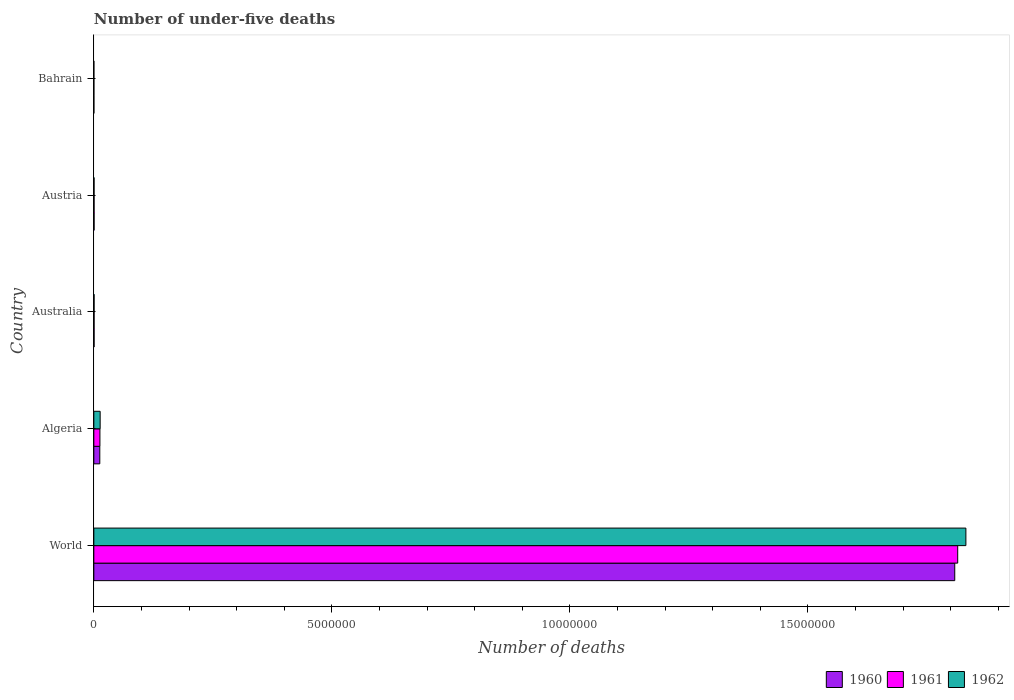How many different coloured bars are there?
Ensure brevity in your answer.  3. How many groups of bars are there?
Your response must be concise. 5. Are the number of bars on each tick of the Y-axis equal?
Make the answer very short. Yes. How many bars are there on the 4th tick from the top?
Provide a short and direct response. 3. How many bars are there on the 5th tick from the bottom?
Offer a very short reply. 3. What is the number of under-five deaths in 1962 in Bahrain?
Provide a succinct answer. 1207. Across all countries, what is the maximum number of under-five deaths in 1962?
Give a very brief answer. 1.83e+07. Across all countries, what is the minimum number of under-five deaths in 1961?
Provide a succinct answer. 1323. In which country was the number of under-five deaths in 1960 minimum?
Make the answer very short. Bahrain. What is the total number of under-five deaths in 1960 in the graph?
Your answer should be compact. 1.82e+07. What is the difference between the number of under-five deaths in 1961 in Algeria and that in Australia?
Ensure brevity in your answer.  1.23e+05. What is the difference between the number of under-five deaths in 1961 in Algeria and the number of under-five deaths in 1962 in World?
Offer a very short reply. -1.82e+07. What is the average number of under-five deaths in 1961 per country?
Provide a short and direct response. 3.66e+06. What is the difference between the number of under-five deaths in 1962 and number of under-five deaths in 1960 in Austria?
Your answer should be compact. -571. What is the ratio of the number of under-five deaths in 1960 in Bahrain to that in World?
Your answer should be compact. 7.79724335926479e-5. What is the difference between the highest and the second highest number of under-five deaths in 1962?
Offer a very short reply. 1.82e+07. What is the difference between the highest and the lowest number of under-five deaths in 1960?
Provide a short and direct response. 1.81e+07. In how many countries, is the number of under-five deaths in 1961 greater than the average number of under-five deaths in 1961 taken over all countries?
Keep it short and to the point. 1. Is the sum of the number of under-five deaths in 1960 in Algeria and Australia greater than the maximum number of under-five deaths in 1962 across all countries?
Provide a succinct answer. No. What does the 3rd bar from the bottom in Australia represents?
Provide a succinct answer. 1962. How many bars are there?
Provide a succinct answer. 15. Are all the bars in the graph horizontal?
Provide a succinct answer. Yes. Does the graph contain any zero values?
Provide a succinct answer. No. Does the graph contain grids?
Ensure brevity in your answer.  No. Where does the legend appear in the graph?
Keep it short and to the point. Bottom right. How many legend labels are there?
Your answer should be very brief. 3. How are the legend labels stacked?
Offer a terse response. Horizontal. What is the title of the graph?
Ensure brevity in your answer.  Number of under-five deaths. Does "2011" appear as one of the legend labels in the graph?
Your answer should be compact. No. What is the label or title of the X-axis?
Make the answer very short. Number of deaths. What is the Number of deaths in 1960 in World?
Offer a terse response. 1.81e+07. What is the Number of deaths of 1961 in World?
Provide a short and direct response. 1.81e+07. What is the Number of deaths of 1962 in World?
Keep it short and to the point. 1.83e+07. What is the Number of deaths of 1960 in Algeria?
Your response must be concise. 1.25e+05. What is the Number of deaths in 1961 in Algeria?
Give a very brief answer. 1.28e+05. What is the Number of deaths in 1962 in Algeria?
Offer a very short reply. 1.33e+05. What is the Number of deaths in 1960 in Australia?
Ensure brevity in your answer.  5775. What is the Number of deaths of 1961 in Australia?
Your response must be concise. 5722. What is the Number of deaths of 1962 in Australia?
Your answer should be compact. 5592. What is the Number of deaths in 1960 in Austria?
Provide a succinct answer. 5754. What is the Number of deaths in 1961 in Austria?
Provide a short and direct response. 5502. What is the Number of deaths in 1962 in Austria?
Your answer should be very brief. 5183. What is the Number of deaths of 1960 in Bahrain?
Your response must be concise. 1410. What is the Number of deaths of 1961 in Bahrain?
Provide a succinct answer. 1323. What is the Number of deaths of 1962 in Bahrain?
Your answer should be very brief. 1207. Across all countries, what is the maximum Number of deaths of 1960?
Ensure brevity in your answer.  1.81e+07. Across all countries, what is the maximum Number of deaths of 1961?
Ensure brevity in your answer.  1.81e+07. Across all countries, what is the maximum Number of deaths in 1962?
Your answer should be very brief. 1.83e+07. Across all countries, what is the minimum Number of deaths in 1960?
Make the answer very short. 1410. Across all countries, what is the minimum Number of deaths of 1961?
Give a very brief answer. 1323. Across all countries, what is the minimum Number of deaths of 1962?
Offer a terse response. 1207. What is the total Number of deaths in 1960 in the graph?
Your answer should be very brief. 1.82e+07. What is the total Number of deaths of 1961 in the graph?
Provide a succinct answer. 1.83e+07. What is the total Number of deaths in 1962 in the graph?
Give a very brief answer. 1.85e+07. What is the difference between the Number of deaths in 1960 in World and that in Algeria?
Your answer should be compact. 1.80e+07. What is the difference between the Number of deaths in 1961 in World and that in Algeria?
Provide a short and direct response. 1.80e+07. What is the difference between the Number of deaths of 1962 in World and that in Algeria?
Offer a terse response. 1.82e+07. What is the difference between the Number of deaths in 1960 in World and that in Australia?
Make the answer very short. 1.81e+07. What is the difference between the Number of deaths of 1961 in World and that in Australia?
Provide a short and direct response. 1.81e+07. What is the difference between the Number of deaths of 1962 in World and that in Australia?
Offer a terse response. 1.83e+07. What is the difference between the Number of deaths of 1960 in World and that in Austria?
Your answer should be very brief. 1.81e+07. What is the difference between the Number of deaths in 1961 in World and that in Austria?
Offer a very short reply. 1.81e+07. What is the difference between the Number of deaths in 1962 in World and that in Austria?
Ensure brevity in your answer.  1.83e+07. What is the difference between the Number of deaths of 1960 in World and that in Bahrain?
Offer a very short reply. 1.81e+07. What is the difference between the Number of deaths of 1961 in World and that in Bahrain?
Give a very brief answer. 1.81e+07. What is the difference between the Number of deaths in 1962 in World and that in Bahrain?
Ensure brevity in your answer.  1.83e+07. What is the difference between the Number of deaths in 1960 in Algeria and that in Australia?
Provide a short and direct response. 1.20e+05. What is the difference between the Number of deaths in 1961 in Algeria and that in Australia?
Your response must be concise. 1.23e+05. What is the difference between the Number of deaths of 1962 in Algeria and that in Australia?
Offer a very short reply. 1.27e+05. What is the difference between the Number of deaths in 1960 in Algeria and that in Austria?
Provide a short and direct response. 1.20e+05. What is the difference between the Number of deaths of 1961 in Algeria and that in Austria?
Your answer should be very brief. 1.23e+05. What is the difference between the Number of deaths of 1962 in Algeria and that in Austria?
Your answer should be compact. 1.28e+05. What is the difference between the Number of deaths in 1960 in Algeria and that in Bahrain?
Provide a succinct answer. 1.24e+05. What is the difference between the Number of deaths of 1961 in Algeria and that in Bahrain?
Provide a short and direct response. 1.27e+05. What is the difference between the Number of deaths in 1962 in Algeria and that in Bahrain?
Make the answer very short. 1.32e+05. What is the difference between the Number of deaths of 1961 in Australia and that in Austria?
Keep it short and to the point. 220. What is the difference between the Number of deaths of 1962 in Australia and that in Austria?
Offer a terse response. 409. What is the difference between the Number of deaths in 1960 in Australia and that in Bahrain?
Offer a very short reply. 4365. What is the difference between the Number of deaths in 1961 in Australia and that in Bahrain?
Keep it short and to the point. 4399. What is the difference between the Number of deaths of 1962 in Australia and that in Bahrain?
Make the answer very short. 4385. What is the difference between the Number of deaths in 1960 in Austria and that in Bahrain?
Keep it short and to the point. 4344. What is the difference between the Number of deaths in 1961 in Austria and that in Bahrain?
Provide a succinct answer. 4179. What is the difference between the Number of deaths of 1962 in Austria and that in Bahrain?
Provide a short and direct response. 3976. What is the difference between the Number of deaths in 1960 in World and the Number of deaths in 1961 in Algeria?
Offer a terse response. 1.80e+07. What is the difference between the Number of deaths of 1960 in World and the Number of deaths of 1962 in Algeria?
Make the answer very short. 1.80e+07. What is the difference between the Number of deaths of 1961 in World and the Number of deaths of 1962 in Algeria?
Offer a very short reply. 1.80e+07. What is the difference between the Number of deaths in 1960 in World and the Number of deaths in 1961 in Australia?
Provide a succinct answer. 1.81e+07. What is the difference between the Number of deaths of 1960 in World and the Number of deaths of 1962 in Australia?
Offer a terse response. 1.81e+07. What is the difference between the Number of deaths in 1961 in World and the Number of deaths in 1962 in Australia?
Your answer should be very brief. 1.81e+07. What is the difference between the Number of deaths of 1960 in World and the Number of deaths of 1961 in Austria?
Give a very brief answer. 1.81e+07. What is the difference between the Number of deaths in 1960 in World and the Number of deaths in 1962 in Austria?
Your response must be concise. 1.81e+07. What is the difference between the Number of deaths in 1961 in World and the Number of deaths in 1962 in Austria?
Your response must be concise. 1.81e+07. What is the difference between the Number of deaths of 1960 in World and the Number of deaths of 1961 in Bahrain?
Provide a succinct answer. 1.81e+07. What is the difference between the Number of deaths of 1960 in World and the Number of deaths of 1962 in Bahrain?
Provide a succinct answer. 1.81e+07. What is the difference between the Number of deaths of 1961 in World and the Number of deaths of 1962 in Bahrain?
Keep it short and to the point. 1.81e+07. What is the difference between the Number of deaths of 1960 in Algeria and the Number of deaths of 1961 in Australia?
Make the answer very short. 1.20e+05. What is the difference between the Number of deaths in 1960 in Algeria and the Number of deaths in 1962 in Australia?
Your answer should be compact. 1.20e+05. What is the difference between the Number of deaths in 1961 in Algeria and the Number of deaths in 1962 in Australia?
Your answer should be very brief. 1.23e+05. What is the difference between the Number of deaths of 1960 in Algeria and the Number of deaths of 1961 in Austria?
Ensure brevity in your answer.  1.20e+05. What is the difference between the Number of deaths in 1960 in Algeria and the Number of deaths in 1962 in Austria?
Your response must be concise. 1.20e+05. What is the difference between the Number of deaths of 1961 in Algeria and the Number of deaths of 1962 in Austria?
Your answer should be compact. 1.23e+05. What is the difference between the Number of deaths in 1960 in Algeria and the Number of deaths in 1961 in Bahrain?
Offer a terse response. 1.24e+05. What is the difference between the Number of deaths of 1960 in Algeria and the Number of deaths of 1962 in Bahrain?
Offer a very short reply. 1.24e+05. What is the difference between the Number of deaths of 1961 in Algeria and the Number of deaths of 1962 in Bahrain?
Offer a terse response. 1.27e+05. What is the difference between the Number of deaths in 1960 in Australia and the Number of deaths in 1961 in Austria?
Keep it short and to the point. 273. What is the difference between the Number of deaths of 1960 in Australia and the Number of deaths of 1962 in Austria?
Offer a terse response. 592. What is the difference between the Number of deaths of 1961 in Australia and the Number of deaths of 1962 in Austria?
Keep it short and to the point. 539. What is the difference between the Number of deaths of 1960 in Australia and the Number of deaths of 1961 in Bahrain?
Provide a short and direct response. 4452. What is the difference between the Number of deaths in 1960 in Australia and the Number of deaths in 1962 in Bahrain?
Provide a short and direct response. 4568. What is the difference between the Number of deaths in 1961 in Australia and the Number of deaths in 1962 in Bahrain?
Your answer should be very brief. 4515. What is the difference between the Number of deaths of 1960 in Austria and the Number of deaths of 1961 in Bahrain?
Give a very brief answer. 4431. What is the difference between the Number of deaths of 1960 in Austria and the Number of deaths of 1962 in Bahrain?
Offer a very short reply. 4547. What is the difference between the Number of deaths of 1961 in Austria and the Number of deaths of 1962 in Bahrain?
Offer a terse response. 4295. What is the average Number of deaths of 1960 per country?
Your answer should be compact. 3.64e+06. What is the average Number of deaths in 1961 per country?
Make the answer very short. 3.66e+06. What is the average Number of deaths in 1962 per country?
Give a very brief answer. 3.69e+06. What is the difference between the Number of deaths in 1960 and Number of deaths in 1961 in World?
Give a very brief answer. -6.21e+04. What is the difference between the Number of deaths of 1960 and Number of deaths of 1962 in World?
Offer a very short reply. -2.34e+05. What is the difference between the Number of deaths of 1961 and Number of deaths of 1962 in World?
Keep it short and to the point. -1.72e+05. What is the difference between the Number of deaths of 1960 and Number of deaths of 1961 in Algeria?
Your answer should be very brief. -2789. What is the difference between the Number of deaths of 1960 and Number of deaths of 1962 in Algeria?
Keep it short and to the point. -7580. What is the difference between the Number of deaths of 1961 and Number of deaths of 1962 in Algeria?
Make the answer very short. -4791. What is the difference between the Number of deaths of 1960 and Number of deaths of 1961 in Australia?
Provide a succinct answer. 53. What is the difference between the Number of deaths in 1960 and Number of deaths in 1962 in Australia?
Ensure brevity in your answer.  183. What is the difference between the Number of deaths of 1961 and Number of deaths of 1962 in Australia?
Your answer should be very brief. 130. What is the difference between the Number of deaths of 1960 and Number of deaths of 1961 in Austria?
Your answer should be very brief. 252. What is the difference between the Number of deaths in 1960 and Number of deaths in 1962 in Austria?
Ensure brevity in your answer.  571. What is the difference between the Number of deaths of 1961 and Number of deaths of 1962 in Austria?
Provide a short and direct response. 319. What is the difference between the Number of deaths in 1960 and Number of deaths in 1962 in Bahrain?
Your answer should be very brief. 203. What is the difference between the Number of deaths in 1961 and Number of deaths in 1962 in Bahrain?
Keep it short and to the point. 116. What is the ratio of the Number of deaths of 1960 in World to that in Algeria?
Your answer should be very brief. 144.14. What is the ratio of the Number of deaths of 1961 in World to that in Algeria?
Provide a short and direct response. 141.49. What is the ratio of the Number of deaths in 1962 in World to that in Algeria?
Offer a very short reply. 137.69. What is the ratio of the Number of deaths of 1960 in World to that in Australia?
Make the answer very short. 3131.31. What is the ratio of the Number of deaths of 1961 in World to that in Australia?
Your answer should be compact. 3171.17. What is the ratio of the Number of deaths of 1962 in World to that in Australia?
Give a very brief answer. 3275.65. What is the ratio of the Number of deaths in 1960 in World to that in Austria?
Your answer should be compact. 3142.74. What is the ratio of the Number of deaths of 1961 in World to that in Austria?
Your answer should be very brief. 3297.97. What is the ratio of the Number of deaths in 1962 in World to that in Austria?
Keep it short and to the point. 3534.14. What is the ratio of the Number of deaths of 1960 in World to that in Bahrain?
Your answer should be very brief. 1.28e+04. What is the ratio of the Number of deaths of 1961 in World to that in Bahrain?
Offer a very short reply. 1.37e+04. What is the ratio of the Number of deaths in 1962 in World to that in Bahrain?
Provide a short and direct response. 1.52e+04. What is the ratio of the Number of deaths of 1960 in Algeria to that in Australia?
Provide a succinct answer. 21.72. What is the ratio of the Number of deaths in 1961 in Algeria to that in Australia?
Keep it short and to the point. 22.41. What is the ratio of the Number of deaths of 1962 in Algeria to that in Australia?
Offer a very short reply. 23.79. What is the ratio of the Number of deaths in 1960 in Algeria to that in Austria?
Provide a short and direct response. 21.8. What is the ratio of the Number of deaths of 1961 in Algeria to that in Austria?
Offer a terse response. 23.31. What is the ratio of the Number of deaths in 1962 in Algeria to that in Austria?
Offer a very short reply. 25.67. What is the ratio of the Number of deaths of 1960 in Algeria to that in Bahrain?
Your response must be concise. 88.97. What is the ratio of the Number of deaths of 1961 in Algeria to that in Bahrain?
Make the answer very short. 96.93. What is the ratio of the Number of deaths in 1962 in Algeria to that in Bahrain?
Your answer should be very brief. 110.22. What is the ratio of the Number of deaths in 1960 in Australia to that in Austria?
Your answer should be very brief. 1. What is the ratio of the Number of deaths of 1961 in Australia to that in Austria?
Keep it short and to the point. 1.04. What is the ratio of the Number of deaths in 1962 in Australia to that in Austria?
Ensure brevity in your answer.  1.08. What is the ratio of the Number of deaths in 1960 in Australia to that in Bahrain?
Give a very brief answer. 4.1. What is the ratio of the Number of deaths in 1961 in Australia to that in Bahrain?
Make the answer very short. 4.33. What is the ratio of the Number of deaths of 1962 in Australia to that in Bahrain?
Provide a succinct answer. 4.63. What is the ratio of the Number of deaths of 1960 in Austria to that in Bahrain?
Give a very brief answer. 4.08. What is the ratio of the Number of deaths in 1961 in Austria to that in Bahrain?
Provide a succinct answer. 4.16. What is the ratio of the Number of deaths in 1962 in Austria to that in Bahrain?
Give a very brief answer. 4.29. What is the difference between the highest and the second highest Number of deaths in 1960?
Provide a succinct answer. 1.80e+07. What is the difference between the highest and the second highest Number of deaths of 1961?
Provide a succinct answer. 1.80e+07. What is the difference between the highest and the second highest Number of deaths of 1962?
Provide a succinct answer. 1.82e+07. What is the difference between the highest and the lowest Number of deaths of 1960?
Your response must be concise. 1.81e+07. What is the difference between the highest and the lowest Number of deaths in 1961?
Your answer should be compact. 1.81e+07. What is the difference between the highest and the lowest Number of deaths in 1962?
Provide a succinct answer. 1.83e+07. 